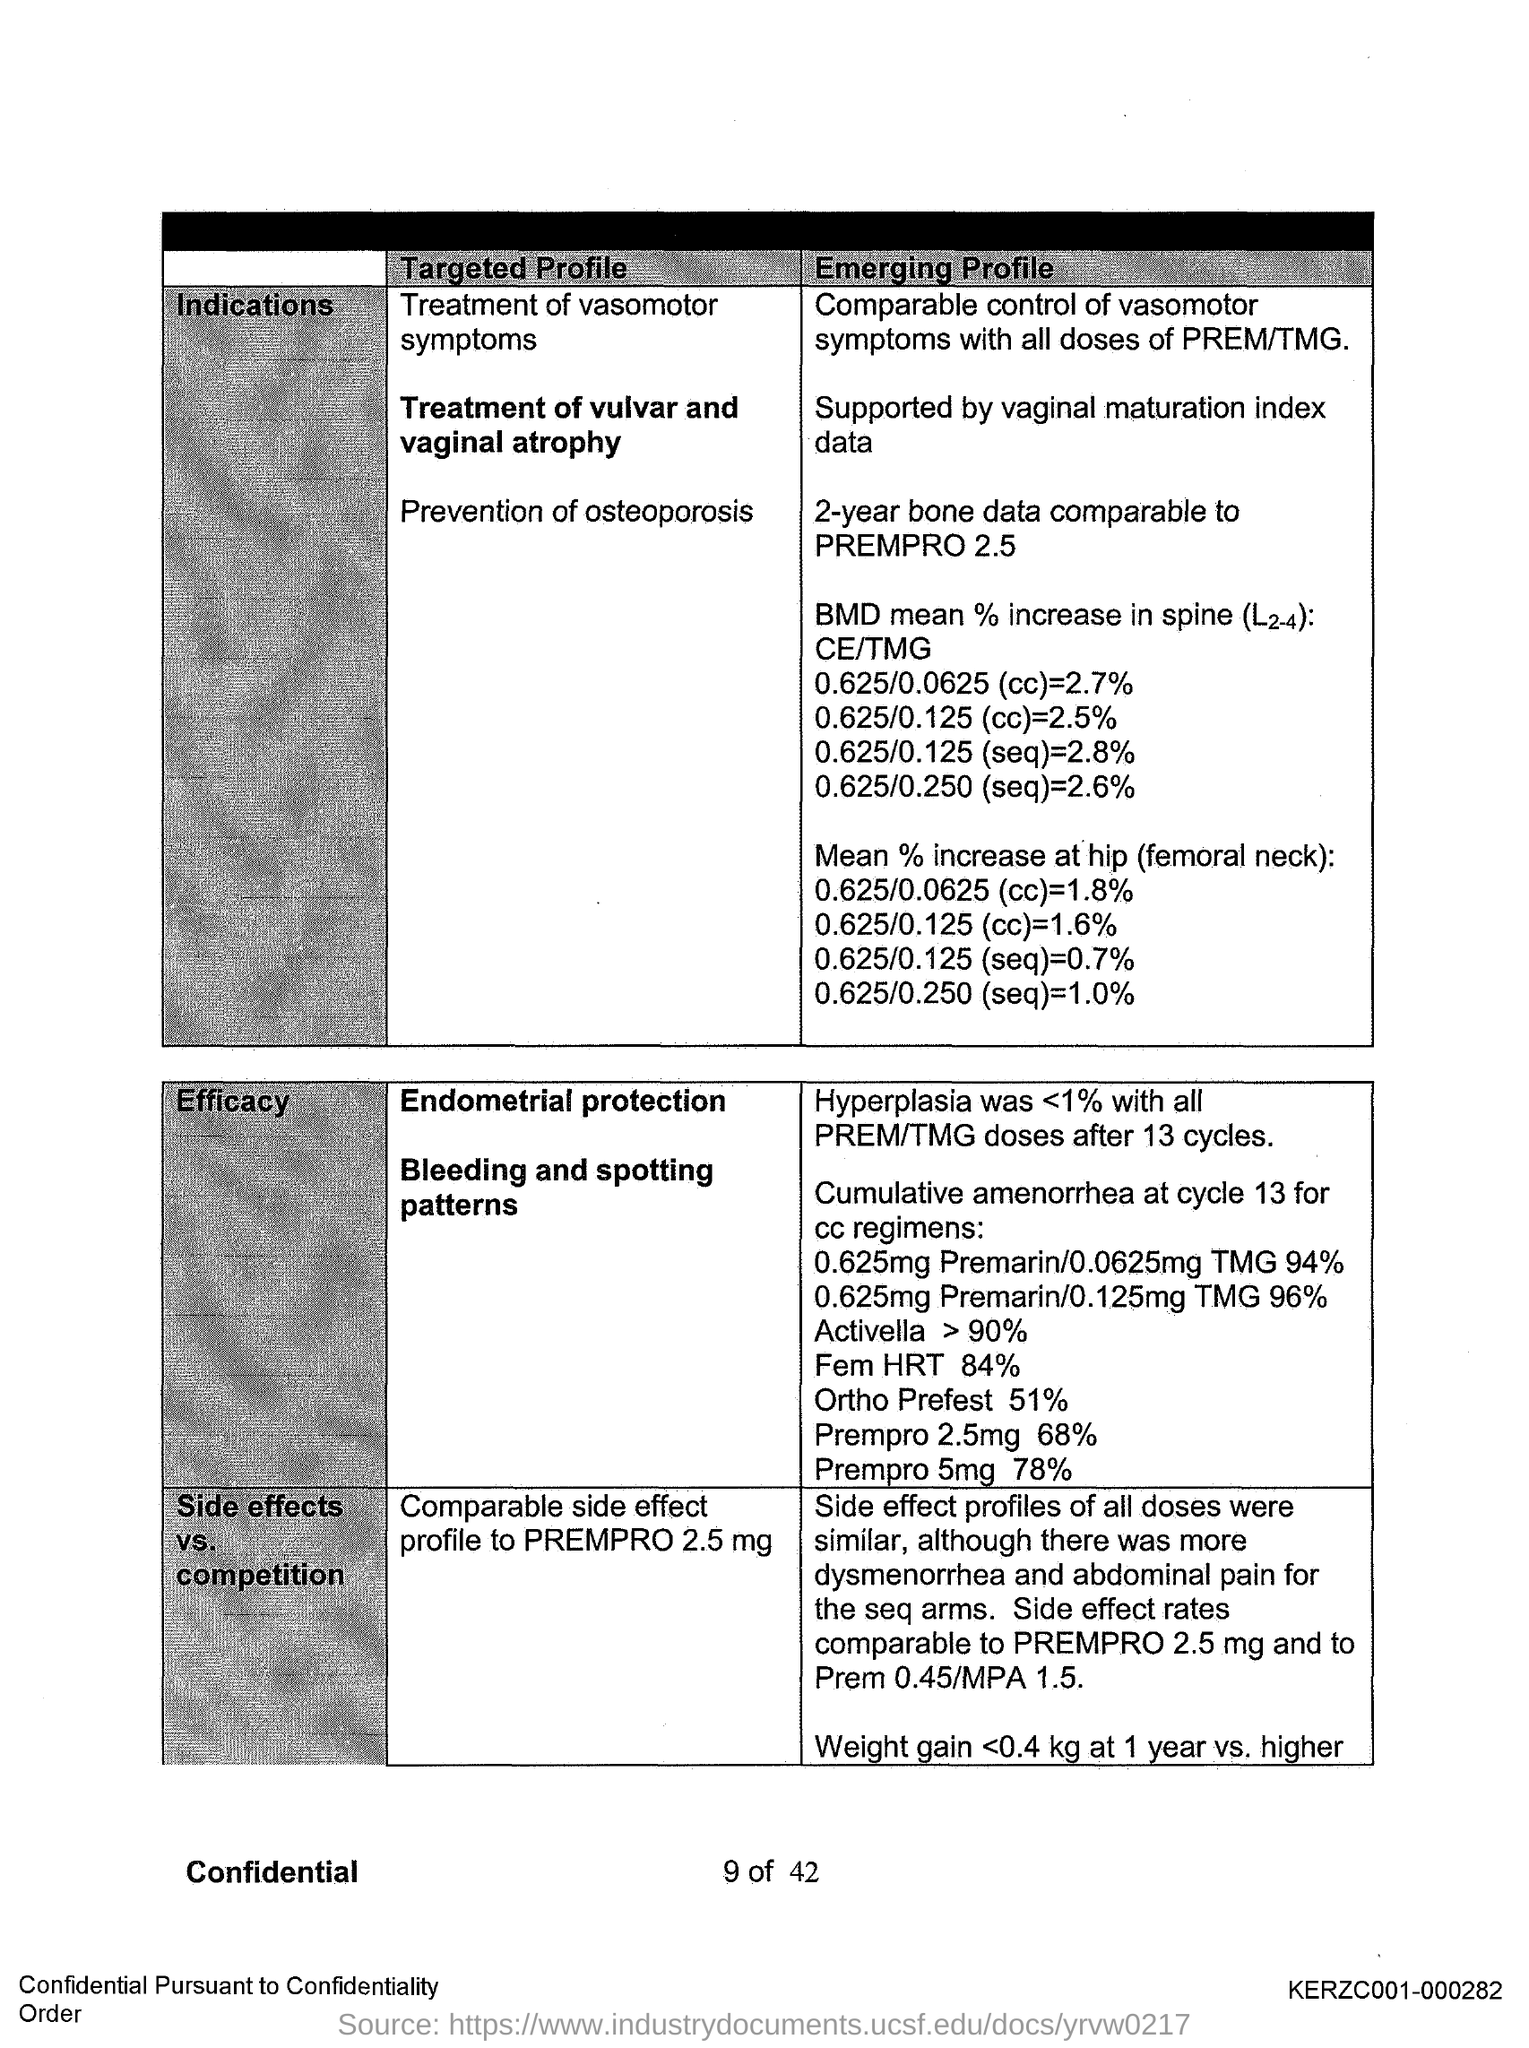Could you describe what this document is about? The document appears to be a medical or scientific report comparing different treatment profiles for various conditions, indicating the efficacy, side effects, and other relevant data of certain dosages.  Can you give more details on the 'Treatment of vulvar and vaginal atrophy' mentioned in the document? The document supports the treatment of vulvar and vaginal atrophy with data, presumably highlighting the effectiveness of certain dosages or regimens in treating this condition. 